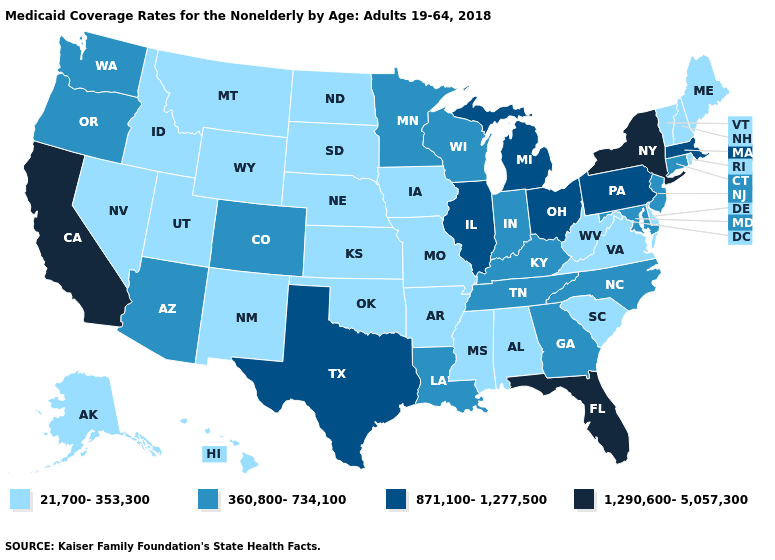What is the value of Nebraska?
Answer briefly. 21,700-353,300. Among the states that border Louisiana , does Texas have the lowest value?
Concise answer only. No. Which states have the lowest value in the South?
Keep it brief. Alabama, Arkansas, Delaware, Mississippi, Oklahoma, South Carolina, Virginia, West Virginia. What is the value of Virginia?
Keep it brief. 21,700-353,300. Does Connecticut have the highest value in the Northeast?
Quick response, please. No. Does Kansas have the lowest value in the MidWest?
Short answer required. Yes. Does Illinois have the lowest value in the MidWest?
Answer briefly. No. Name the states that have a value in the range 360,800-734,100?
Answer briefly. Arizona, Colorado, Connecticut, Georgia, Indiana, Kentucky, Louisiana, Maryland, Minnesota, New Jersey, North Carolina, Oregon, Tennessee, Washington, Wisconsin. Does the first symbol in the legend represent the smallest category?
Answer briefly. Yes. Does Maryland have the lowest value in the USA?
Quick response, please. No. Among the states that border Pennsylvania , which have the lowest value?
Quick response, please. Delaware, West Virginia. Name the states that have a value in the range 21,700-353,300?
Quick response, please. Alabama, Alaska, Arkansas, Delaware, Hawaii, Idaho, Iowa, Kansas, Maine, Mississippi, Missouri, Montana, Nebraska, Nevada, New Hampshire, New Mexico, North Dakota, Oklahoma, Rhode Island, South Carolina, South Dakota, Utah, Vermont, Virginia, West Virginia, Wyoming. Does Illinois have the lowest value in the MidWest?
Give a very brief answer. No. Among the states that border Rhode Island , does Connecticut have the highest value?
Give a very brief answer. No. How many symbols are there in the legend?
Keep it brief. 4. 